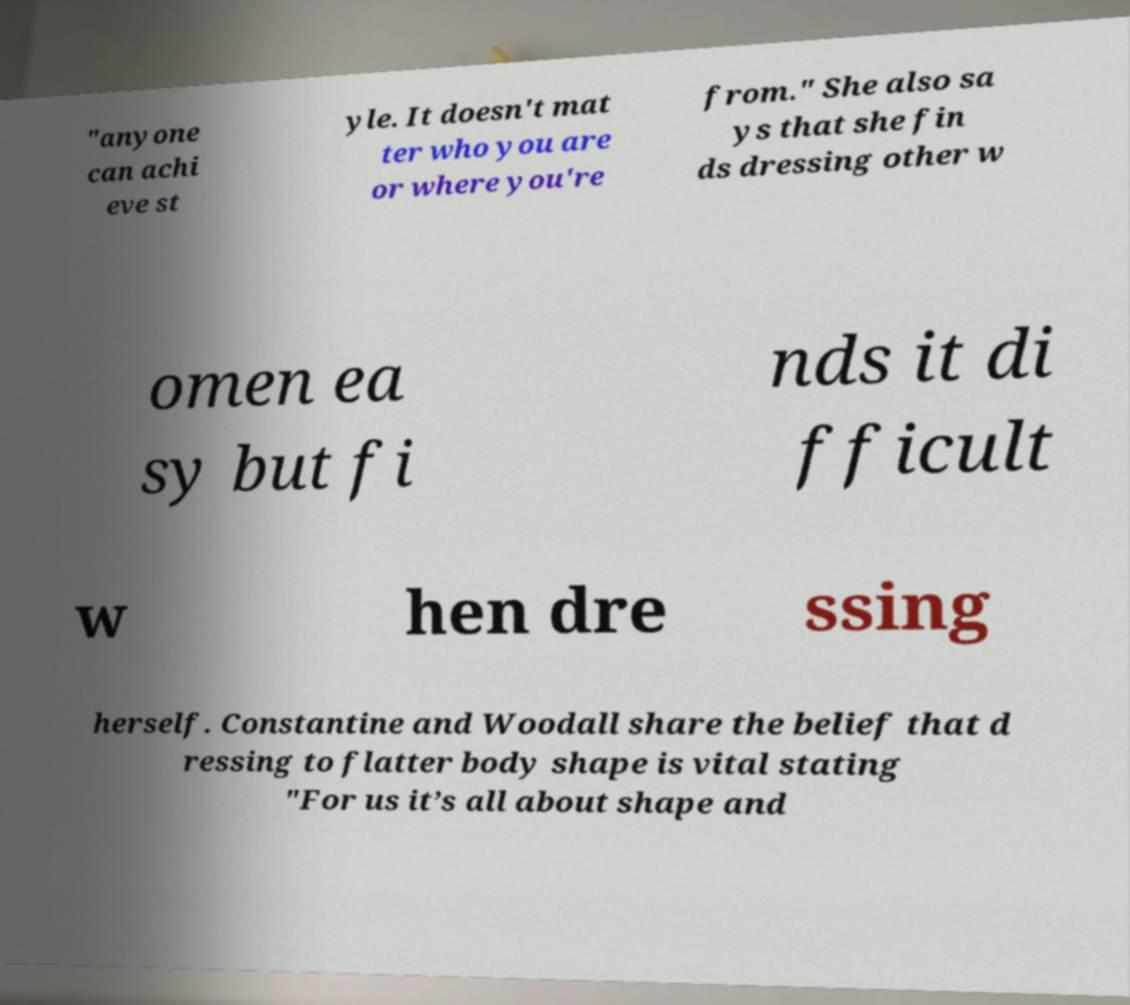Can you accurately transcribe the text from the provided image for me? "anyone can achi eve st yle. It doesn't mat ter who you are or where you're from." She also sa ys that she fin ds dressing other w omen ea sy but fi nds it di fficult w hen dre ssing herself. Constantine and Woodall share the belief that d ressing to flatter body shape is vital stating "For us it’s all about shape and 